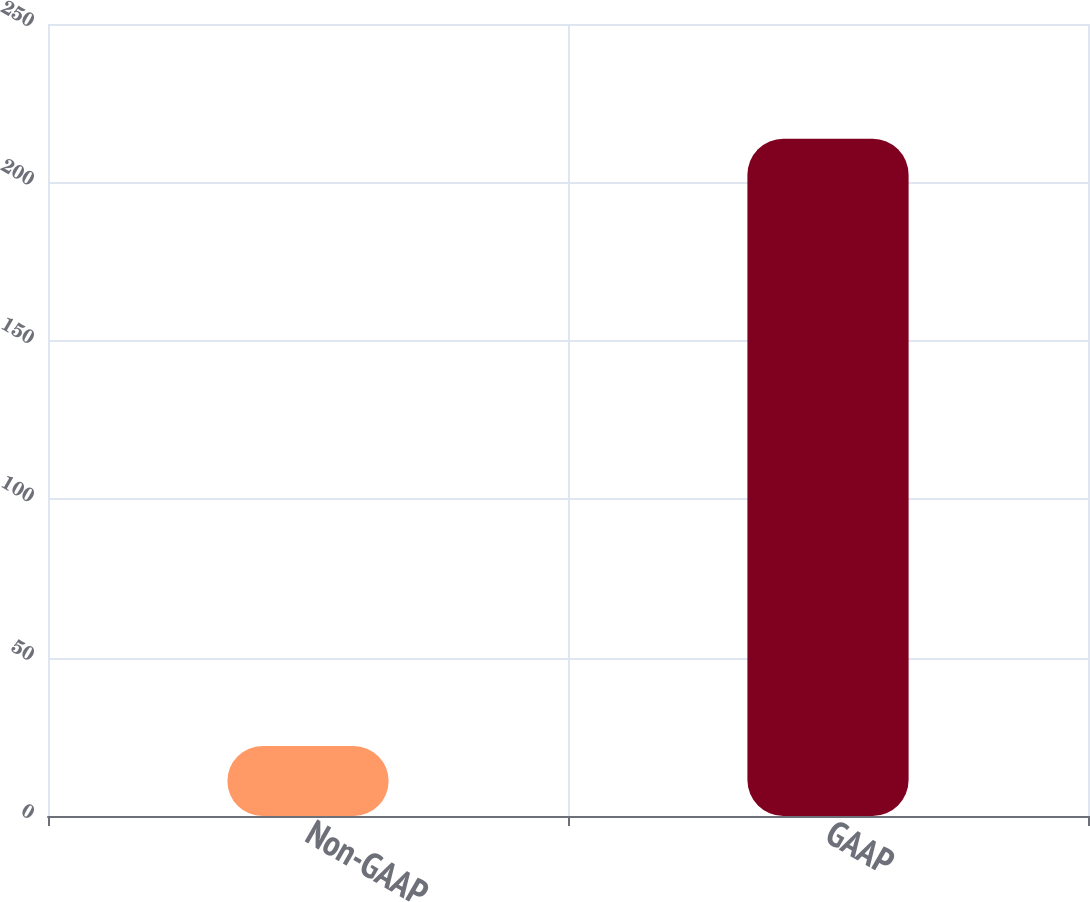<chart> <loc_0><loc_0><loc_500><loc_500><bar_chart><fcel>Non-GAAP<fcel>GAAP<nl><fcel>22.1<fcel>213.8<nl></chart> 